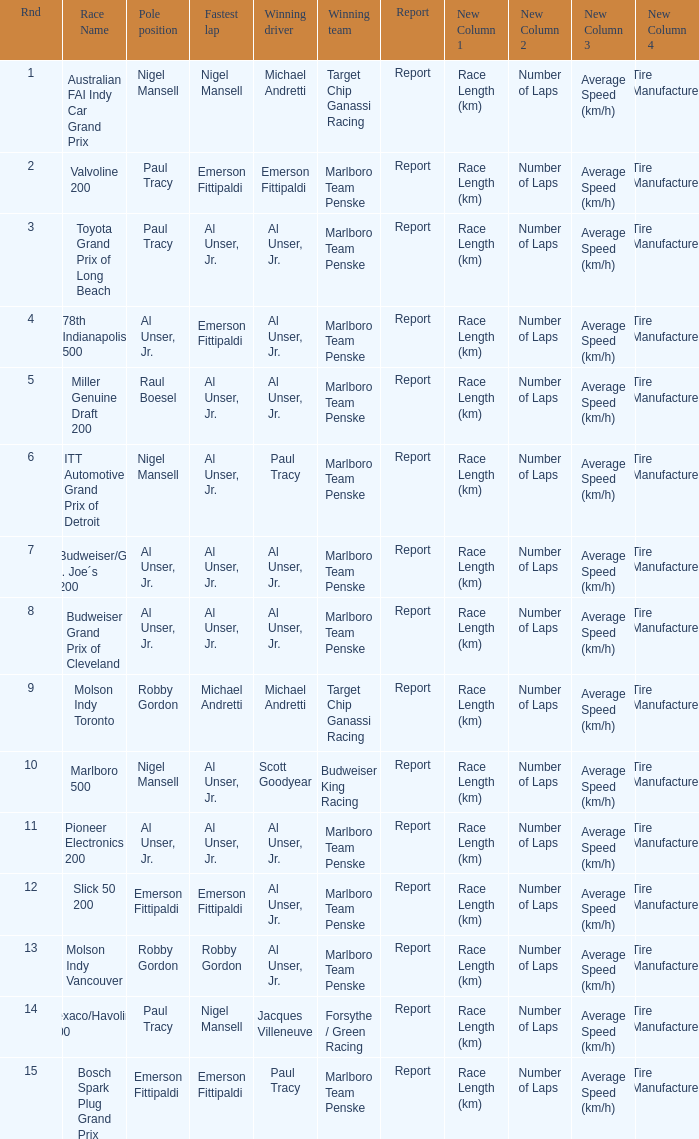Who did the fastest lap in the race won by Paul Tracy, with Emerson Fittipaldi at the pole position? Emerson Fittipaldi. Can you parse all the data within this table? {'header': ['Rnd', 'Race Name', 'Pole position', 'Fastest lap', 'Winning driver', 'Winning team', 'Report', 'New Column 1', 'New Column 2', 'New Column 3', 'New Column 4'], 'rows': [['1', 'Australian FAI Indy Car Grand Prix', 'Nigel Mansell', 'Nigel Mansell', 'Michael Andretti', 'Target Chip Ganassi Racing', 'Report', 'Race Length (km)', 'Number of Laps', 'Average Speed (km/h)', 'Tire Manufacturer'], ['2', 'Valvoline 200', 'Paul Tracy', 'Emerson Fittipaldi', 'Emerson Fittipaldi', 'Marlboro Team Penske', 'Report', 'Race Length (km)', 'Number of Laps', 'Average Speed (km/h)', 'Tire Manufacturer'], ['3', 'Toyota Grand Prix of Long Beach', 'Paul Tracy', 'Al Unser, Jr.', 'Al Unser, Jr.', 'Marlboro Team Penske', 'Report', 'Race Length (km)', 'Number of Laps', 'Average Speed (km/h)', 'Tire Manufacturer'], ['4', '78th Indianapolis 500', 'Al Unser, Jr.', 'Emerson Fittipaldi', 'Al Unser, Jr.', 'Marlboro Team Penske', 'Report', 'Race Length (km)', 'Number of Laps', 'Average Speed (km/h)', 'Tire Manufacturer'], ['5', 'Miller Genuine Draft 200', 'Raul Boesel', 'Al Unser, Jr.', 'Al Unser, Jr.', 'Marlboro Team Penske', 'Report', 'Race Length (km)', 'Number of Laps', 'Average Speed (km/h)', 'Tire Manufacturer'], ['6', 'ITT Automotive Grand Prix of Detroit', 'Nigel Mansell', 'Al Unser, Jr.', 'Paul Tracy', 'Marlboro Team Penske', 'Report', 'Race Length (km)', 'Number of Laps', 'Average Speed (km/h)', 'Tire Manufacturer'], ['7', 'Budweiser/G. I. Joe´s 200', 'Al Unser, Jr.', 'Al Unser, Jr.', 'Al Unser, Jr.', 'Marlboro Team Penske', 'Report', 'Race Length (km)', 'Number of Laps', 'Average Speed (km/h)', 'Tire Manufacturer'], ['8', 'Budweiser Grand Prix of Cleveland', 'Al Unser, Jr.', 'Al Unser, Jr.', 'Al Unser, Jr.', 'Marlboro Team Penske', 'Report', 'Race Length (km)', 'Number of Laps', 'Average Speed (km/h)', 'Tire Manufacturer'], ['9', 'Molson Indy Toronto', 'Robby Gordon', 'Michael Andretti', 'Michael Andretti', 'Target Chip Ganassi Racing', 'Report', 'Race Length (km)', 'Number of Laps', 'Average Speed (km/h)', 'Tire Manufacturer'], ['10', 'Marlboro 500', 'Nigel Mansell', 'Al Unser, Jr.', 'Scott Goodyear', 'Budweiser King Racing', 'Report', 'Race Length (km)', 'Number of Laps', 'Average Speed (km/h)', 'Tire Manufacturer'], ['11', 'Pioneer Electronics 200', 'Al Unser, Jr.', 'Al Unser, Jr.', 'Al Unser, Jr.', 'Marlboro Team Penske', 'Report', 'Race Length (km)', 'Number of Laps', 'Average Speed (km/h)', 'Tire Manufacturer'], ['12', 'Slick 50 200', 'Emerson Fittipaldi', 'Emerson Fittipaldi', 'Al Unser, Jr.', 'Marlboro Team Penske', 'Report', 'Race Length (km)', 'Number of Laps', 'Average Speed (km/h)', 'Tire Manufacturer'], ['13', 'Molson Indy Vancouver', 'Robby Gordon', 'Robby Gordon', 'Al Unser, Jr.', 'Marlboro Team Penske', 'Report', 'Race Length (km)', 'Number of Laps', 'Average Speed (km/h)', 'Tire Manufacturer'], ['14', 'Texaco/Havoline 200', 'Paul Tracy', 'Nigel Mansell', 'Jacques Villeneuve', 'Forsythe / Green Racing', 'Report', 'Race Length (km)', 'Number of Laps', 'Average Speed (km/h)', 'Tire Manufacturer'], ['15', 'Bosch Spark Plug Grand Prix', 'Emerson Fittipaldi', 'Emerson Fittipaldi', 'Paul Tracy', 'Marlboro Team Penske', 'Report', 'Race Length (km)', 'Number of Laps', 'Average Speed (km/h)', 'Tire Manufacturer']]} 